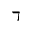<formula> <loc_0><loc_0><loc_500><loc_500>\daleth</formula> 